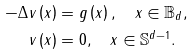<formula> <loc_0><loc_0><loc_500><loc_500>- \Delta v \left ( x \right ) & = g \left ( x \right ) , \quad x \in \mathbb { B } _ { d } , \\ v \left ( x \right ) & = 0 , \quad x \in \mathbb { S } ^ { d - 1 } .</formula> 